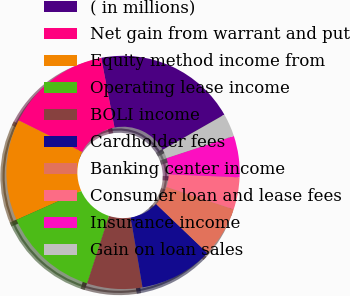<chart> <loc_0><loc_0><loc_500><loc_500><pie_chart><fcel>( in millions)<fcel>Net gain from warrant and put<fcel>Equity method income from<fcel>Operating lease income<fcel>BOLI income<fcel>Cardholder fees<fcel>Banking center income<fcel>Consumer loan and lease fees<fcel>Insurance income<fcel>Gain on loan sales<nl><fcel>19.74%<fcel>14.65%<fcel>14.01%<fcel>13.37%<fcel>7.64%<fcel>10.19%<fcel>7.01%<fcel>4.46%<fcel>5.73%<fcel>3.19%<nl></chart> 